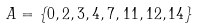<formula> <loc_0><loc_0><loc_500><loc_500>A = \{ 0 , 2 , 3 , 4 , 7 , 1 1 , 1 2 , 1 4 \}</formula> 